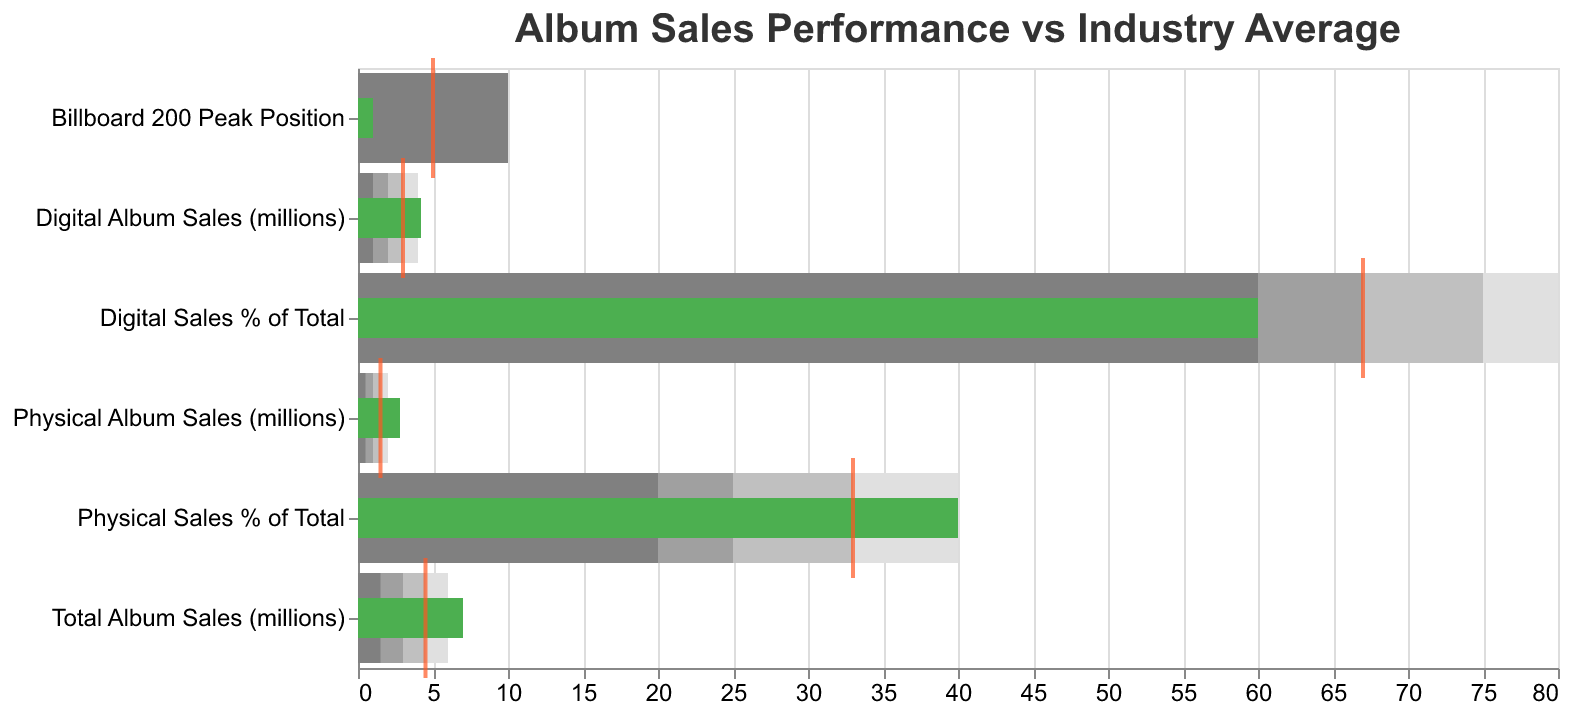How many categories are displayed in the figure? The figure shows data for each title, and there are six titles listed: "Physical Album Sales (millions)", "Digital Album Sales (millions)", "Total Album Sales (millions)", "Physical Sales % of Total", "Digital Sales % of Total", and "Billboard 200 Peak Position".
Answer: Six What is the actual value for "Digital Album Sales (millions)"? The figure shows that the green bar's length represents the actual values. For "Digital Album Sales (millions)", the value is marked as 4.2.
Answer: 4.2 million How does the actual value for "Total Album Sales (millions)" compare with the industry average? The green bar represents the actual value, and the tick mark represents the industry average. For "Total Album Sales (millions)", the green bar shows 7 million, and the tick mark shows 4.5 million, indicating the actual value is higher.
Answer: Higher What is the difference between the actual and comparative values for "Billboard 200 Peak Position"? The actual value (green bar) for "Billboard 200 Peak Position" is 1, and the comparative value (tick mark) is 5. The difference is 5 - 1.
Answer: 4 Which category has its actual value closest to its highest range value? By comparing each category's actual value (green bar) with the highest range value (darkest shaded bar), "Physical Album Sales (millions)" has an actual value of 2.8 closest to the highest range value of 2.0.
Answer: Physical Album Sales (millions) Are digital sales a higher percentage of total sales than physical sales? The actual values are represented by the green bars. "Digital Sales % of Total" shows an actual value of 60%, while "Physical Sales % of Total" shows 40%. Thus, digital sales are a higher percentage of total sales.
Answer: Yes By how much do the actual digital album sales exceed the industry average? The actual digital album sales value (green bar) is 4.2 millions, and the industry average (tick mark) is 3.0 millions. The difference is 4.2 - 3.0.
Answer: 1.2 million Which category demonstrates the highest improvement from the industry average? The greatest difference between the actual value (green bar) and the comparative value (tick mark) shows the highest improvement. The "Billboard 200 Peak Position" shows an improvement of 4 compared to other categories with lower differences.
Answer: Billboard 200 Peak Position 